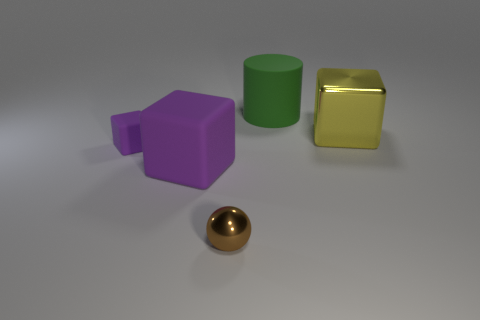The big object that is in front of the green matte cylinder and right of the tiny sphere is what color?
Your response must be concise. Yellow. Are the brown object and the big block that is on the right side of the big purple matte block made of the same material?
Your answer should be compact. Yes. There is a rubber object that is right of the small ball; is its shape the same as the small brown metal object?
Ensure brevity in your answer.  No. Is the number of brown shiny things behind the brown metallic ball less than the number of red spheres?
Offer a terse response. No. Are there any big green cubes made of the same material as the ball?
Your answer should be compact. No. There is a yellow object that is the same size as the green matte object; what is its material?
Your answer should be very brief. Metal. Are there fewer large matte cubes on the right side of the yellow thing than small brown things that are on the left side of the metal sphere?
Provide a short and direct response. No. There is a matte thing that is both on the right side of the small block and behind the big purple thing; what shape is it?
Your response must be concise. Cylinder. How many big metal objects have the same shape as the large purple rubber thing?
Your response must be concise. 1. There is a green cylinder that is made of the same material as the small purple block; what size is it?
Keep it short and to the point. Large. 